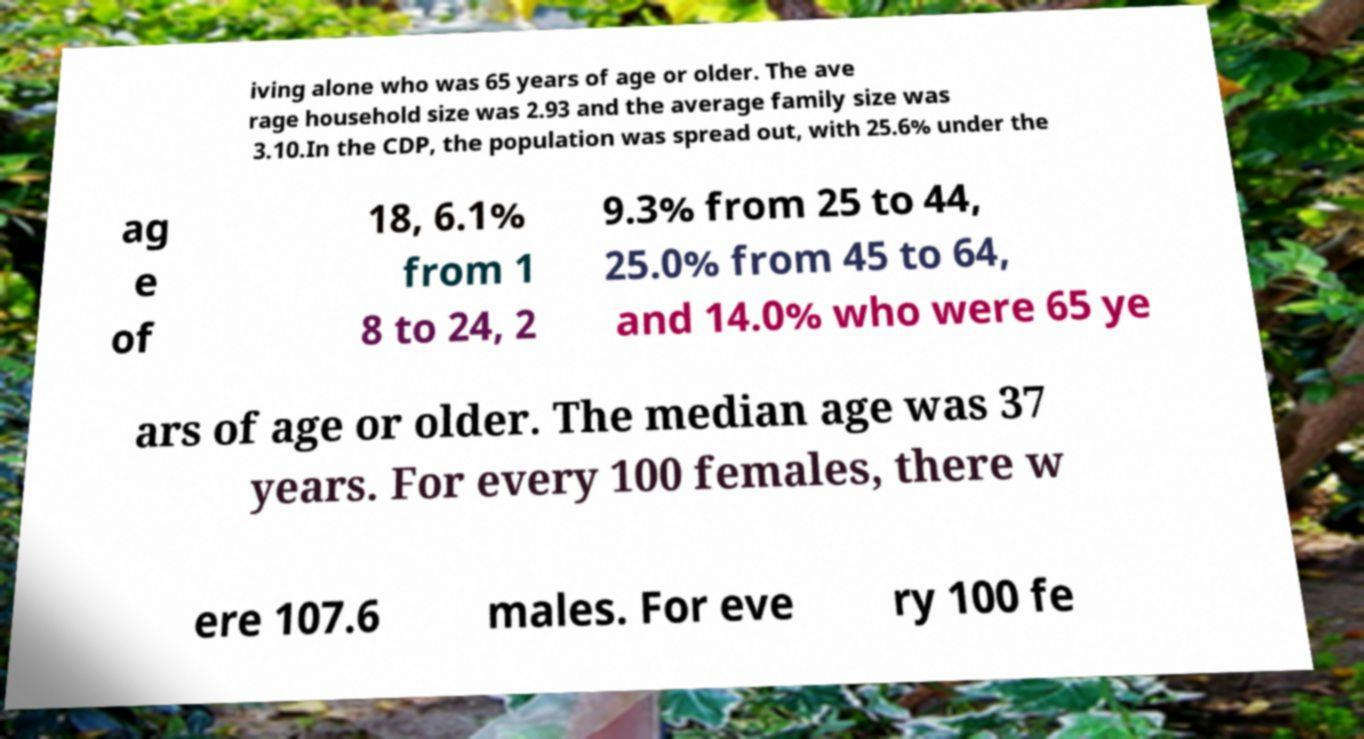Can you accurately transcribe the text from the provided image for me? iving alone who was 65 years of age or older. The ave rage household size was 2.93 and the average family size was 3.10.In the CDP, the population was spread out, with 25.6% under the ag e of 18, 6.1% from 1 8 to 24, 2 9.3% from 25 to 44, 25.0% from 45 to 64, and 14.0% who were 65 ye ars of age or older. The median age was 37 years. For every 100 females, there w ere 107.6 males. For eve ry 100 fe 